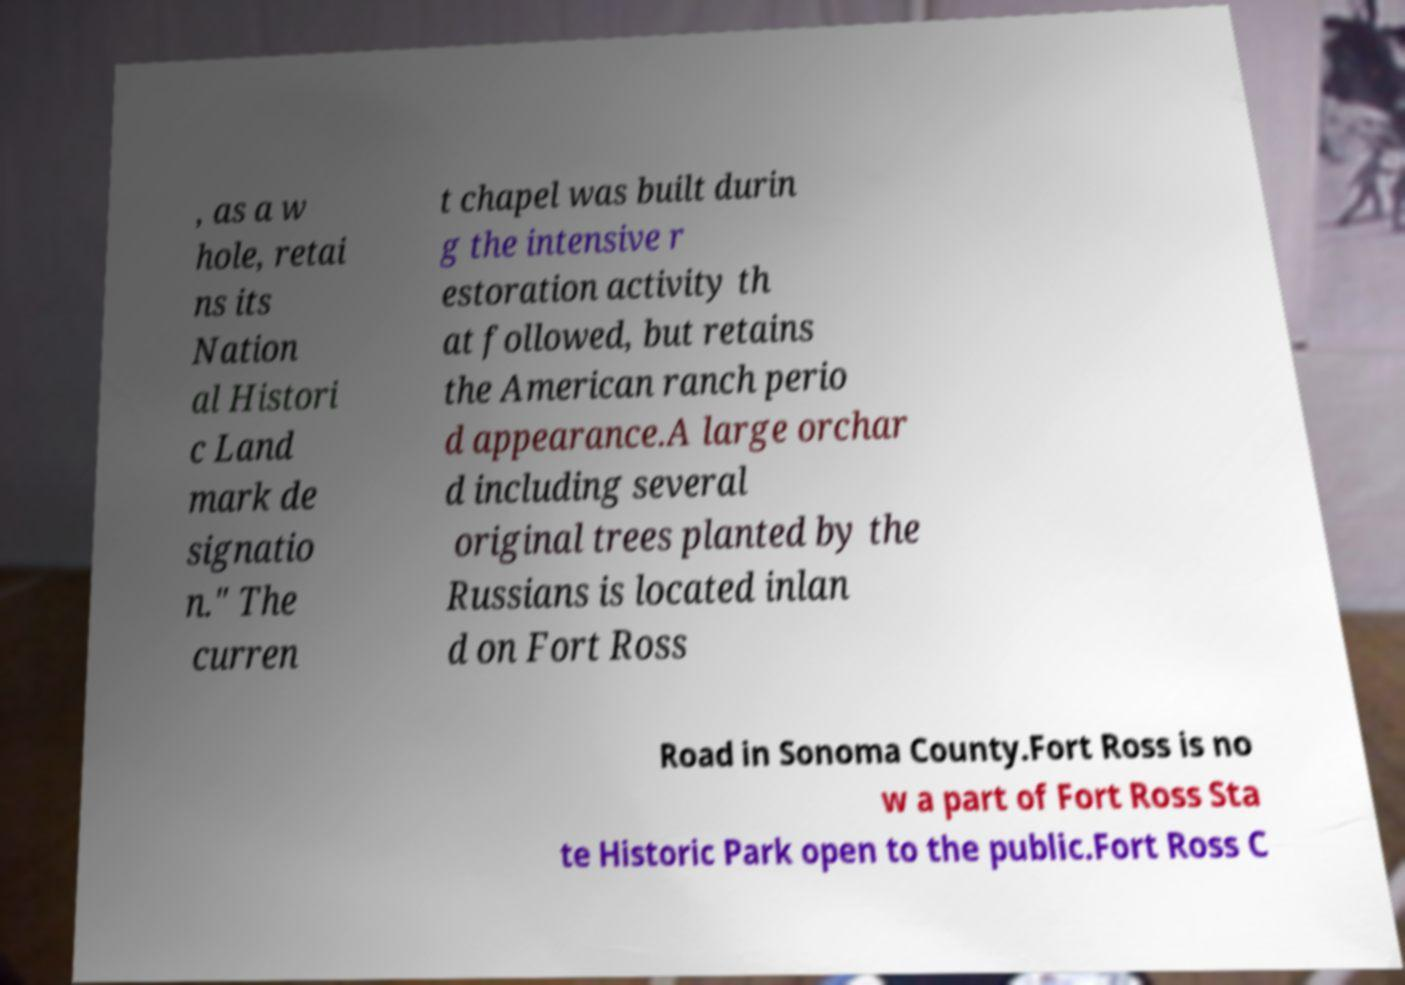Can you accurately transcribe the text from the provided image for me? , as a w hole, retai ns its Nation al Histori c Land mark de signatio n." The curren t chapel was built durin g the intensive r estoration activity th at followed, but retains the American ranch perio d appearance.A large orchar d including several original trees planted by the Russians is located inlan d on Fort Ross Road in Sonoma County.Fort Ross is no w a part of Fort Ross Sta te Historic Park open to the public.Fort Ross C 